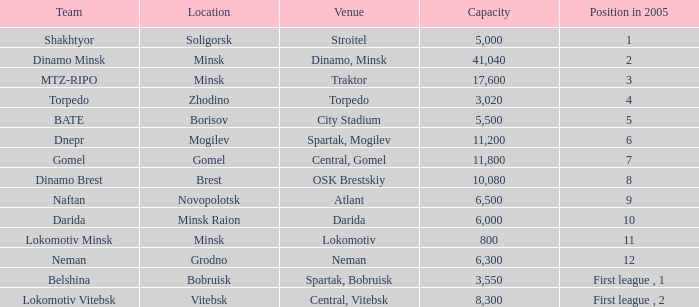Could you help me parse every detail presented in this table? {'header': ['Team', 'Location', 'Venue', 'Capacity', 'Position in 2005'], 'rows': [['Shakhtyor', 'Soligorsk', 'Stroitel', '5,000', '1'], ['Dinamo Minsk', 'Minsk', 'Dinamo, Minsk', '41,040', '2'], ['MTZ-RIPO', 'Minsk', 'Traktor', '17,600', '3'], ['Torpedo', 'Zhodino', 'Torpedo', '3,020', '4'], ['BATE', 'Borisov', 'City Stadium', '5,500', '5'], ['Dnepr', 'Mogilev', 'Spartak, Mogilev', '11,200', '6'], ['Gomel', 'Gomel', 'Central, Gomel', '11,800', '7'], ['Dinamo Brest', 'Brest', 'OSK Brestskiy', '10,080', '8'], ['Naftan', 'Novopolotsk', 'Atlant', '6,500', '9'], ['Darida', 'Minsk Raion', 'Darida', '6,000', '10'], ['Lokomotiv Minsk', 'Minsk', 'Lokomotiv', '800', '11'], ['Neman', 'Grodno', 'Neman', '6,300', '12'], ['Belshina', 'Bobruisk', 'Spartak, Bobruisk', '3,550', 'First league , 1'], ['Lokomotiv Vitebsk', 'Vitebsk', 'Central, Vitebsk', '8,300', 'First league , 2']]} Can you tell me the Venue that has the Position in 2005 of 8? OSK Brestskiy. 